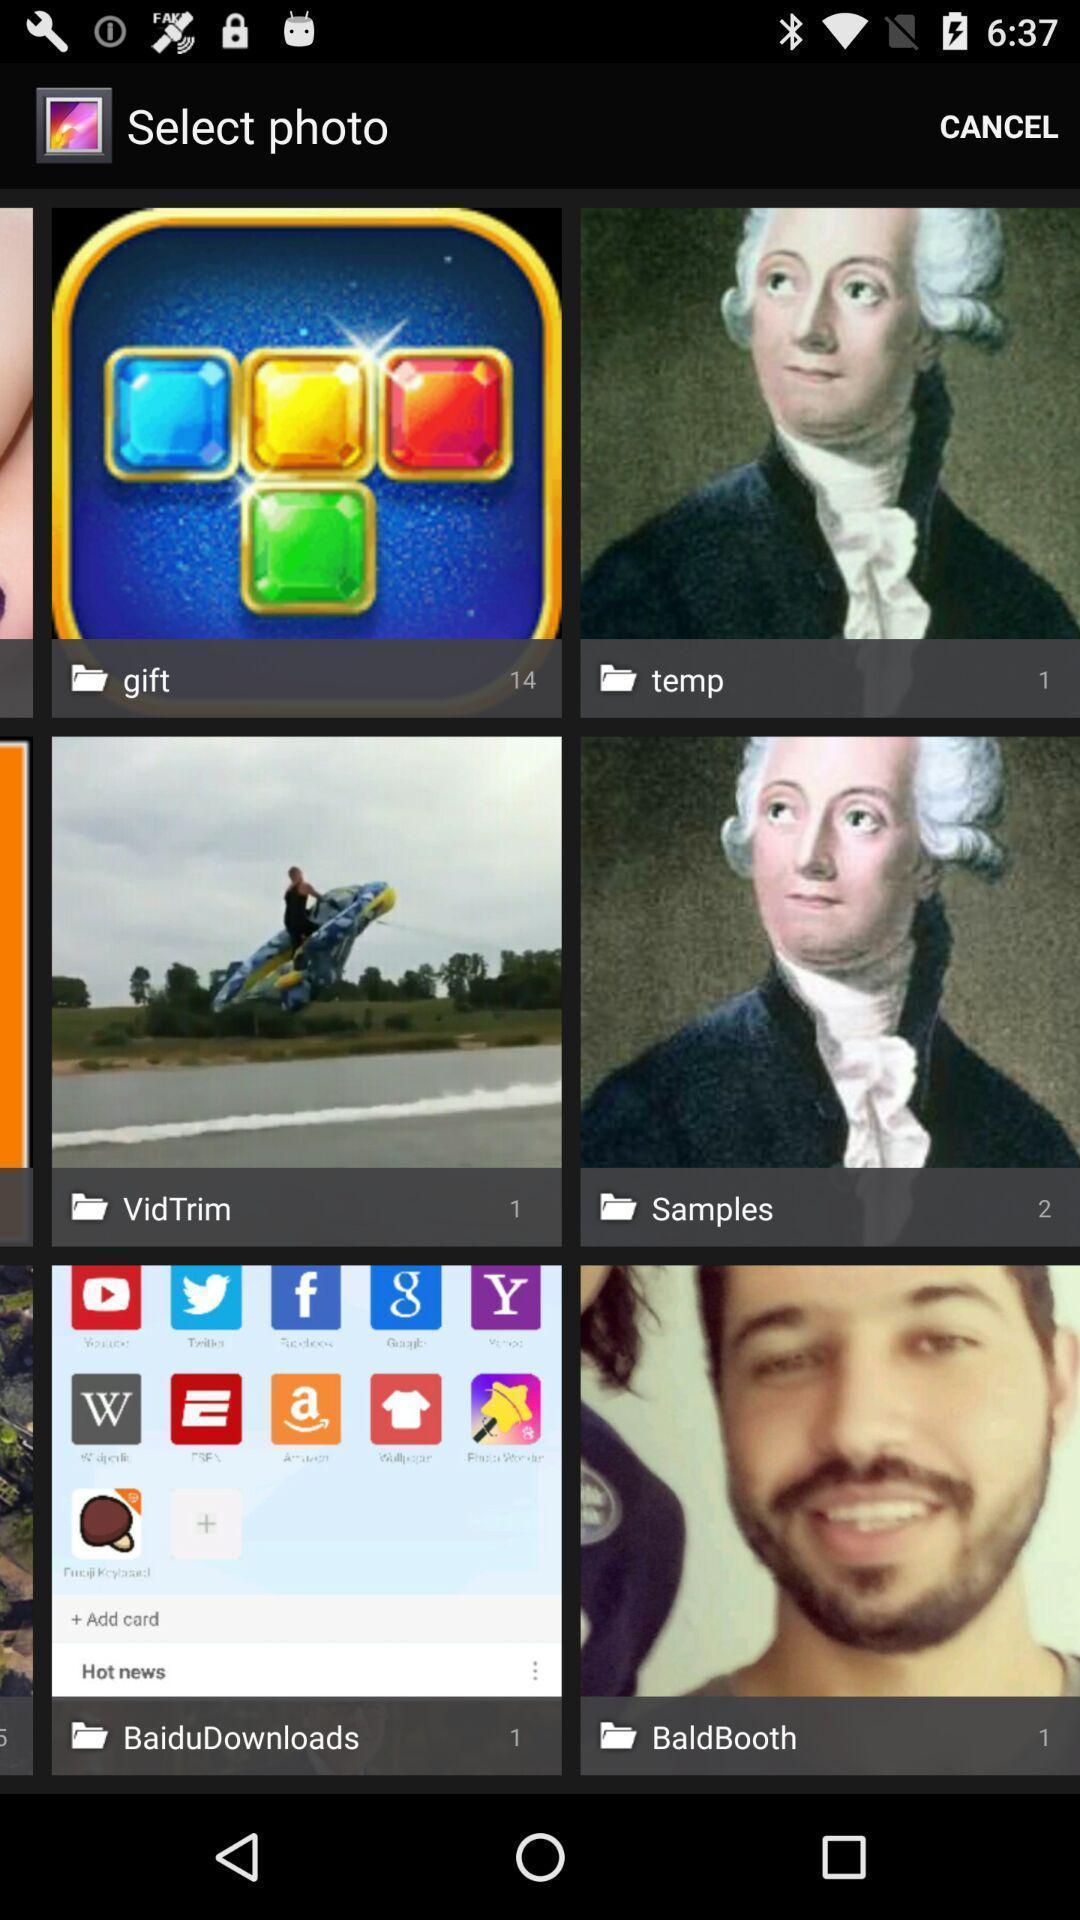Provide a textual representation of this image. Screen shows different types of images. 